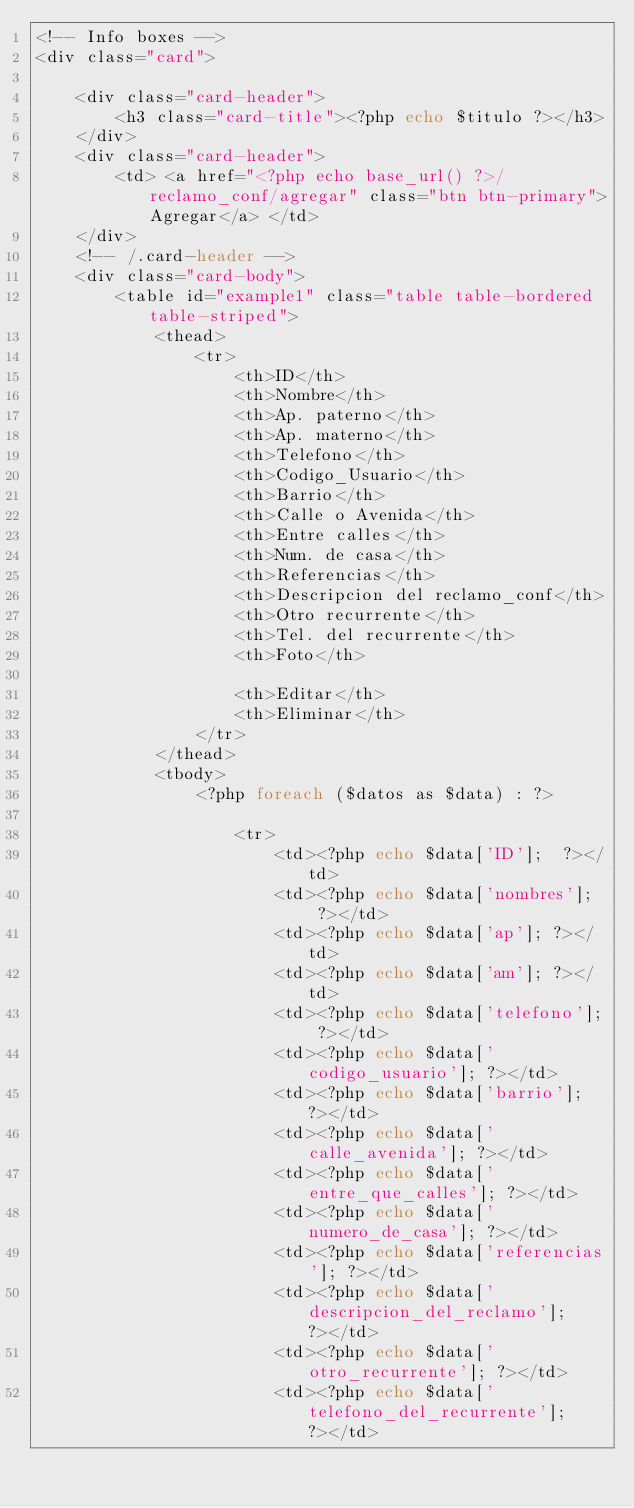Convert code to text. <code><loc_0><loc_0><loc_500><loc_500><_PHP_><!-- Info boxes -->
<div class="card">

    <div class="card-header">
        <h3 class="card-title"><?php echo $titulo ?></h3>
    </div>
    <div class="card-header">
        <td> <a href="<?php echo base_url() ?>/reclamo_conf/agregar" class="btn btn-primary">Agregar</a> </td>
    </div>
    <!-- /.card-header -->
    <div class="card-body">
        <table id="example1" class="table table-bordered table-striped">
            <thead>
                <tr>
                    <th>ID</th>
                    <th>Nombre</th>
                    <th>Ap. paterno</th>
                    <th>Ap. materno</th>
                    <th>Telefono</th>
                    <th>Codigo_Usuario</th>
                    <th>Barrio</th>
                    <th>Calle o Avenida</th>
                    <th>Entre calles</th>
                    <th>Num. de casa</th>
                    <th>Referencias</th>
                    <th>Descripcion del reclamo_conf</th>
                    <th>Otro recurrente</th>
                    <th>Tel. del recurrente</th>
                    <th>Foto</th>

                    <th>Editar</th>
                    <th>Eliminar</th>
                </tr>
            </thead>
            <tbody>
                <?php foreach ($datos as $data) : ?>

                    <tr>
                        <td><?php echo $data['ID'];  ?></td>
                        <td><?php echo $data['nombres'];  ?></td>
                        <td><?php echo $data['ap']; ?></td>
                        <td><?php echo $data['am']; ?></td>
                        <td><?php echo $data['telefono']; ?></td>
                        <td><?php echo $data['codigo_usuario']; ?></td>
                        <td><?php echo $data['barrio']; ?></td>
                        <td><?php echo $data['calle_avenida']; ?></td>
                        <td><?php echo $data['entre_que_calles']; ?></td>
                        <td><?php echo $data['numero_de_casa']; ?></td>
                        <td><?php echo $data['referencias']; ?></td>
                        <td><?php echo $data['descripcion_del_reclamo']; ?></td>
                        <td><?php echo $data['otro_recurrente']; ?></td>
                        <td><?php echo $data['telefono_del_recurrente']; ?></td></code> 